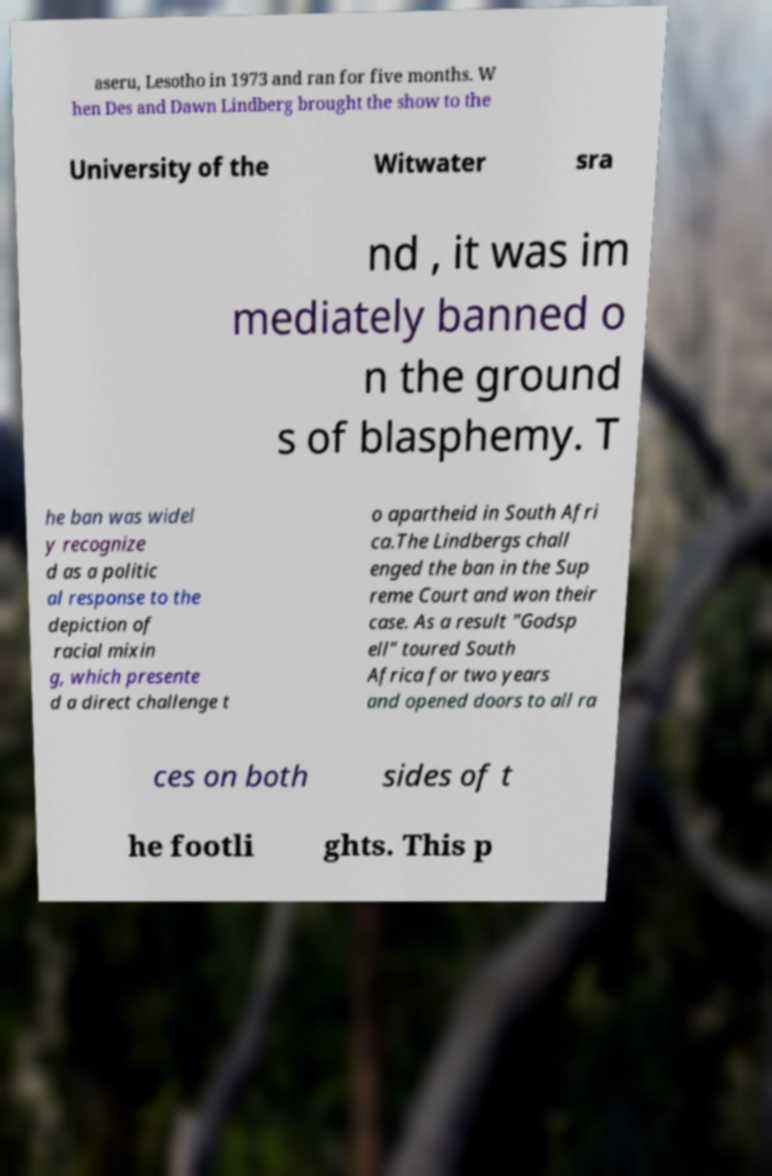Please read and relay the text visible in this image. What does it say? aseru, Lesotho in 1973 and ran for five months. W hen Des and Dawn Lindberg brought the show to the University of the Witwater sra nd , it was im mediately banned o n the ground s of blasphemy. T he ban was widel y recognize d as a politic al response to the depiction of racial mixin g, which presente d a direct challenge t o apartheid in South Afri ca.The Lindbergs chall enged the ban in the Sup reme Court and won their case. As a result "Godsp ell" toured South Africa for two years and opened doors to all ra ces on both sides of t he footli ghts. This p 